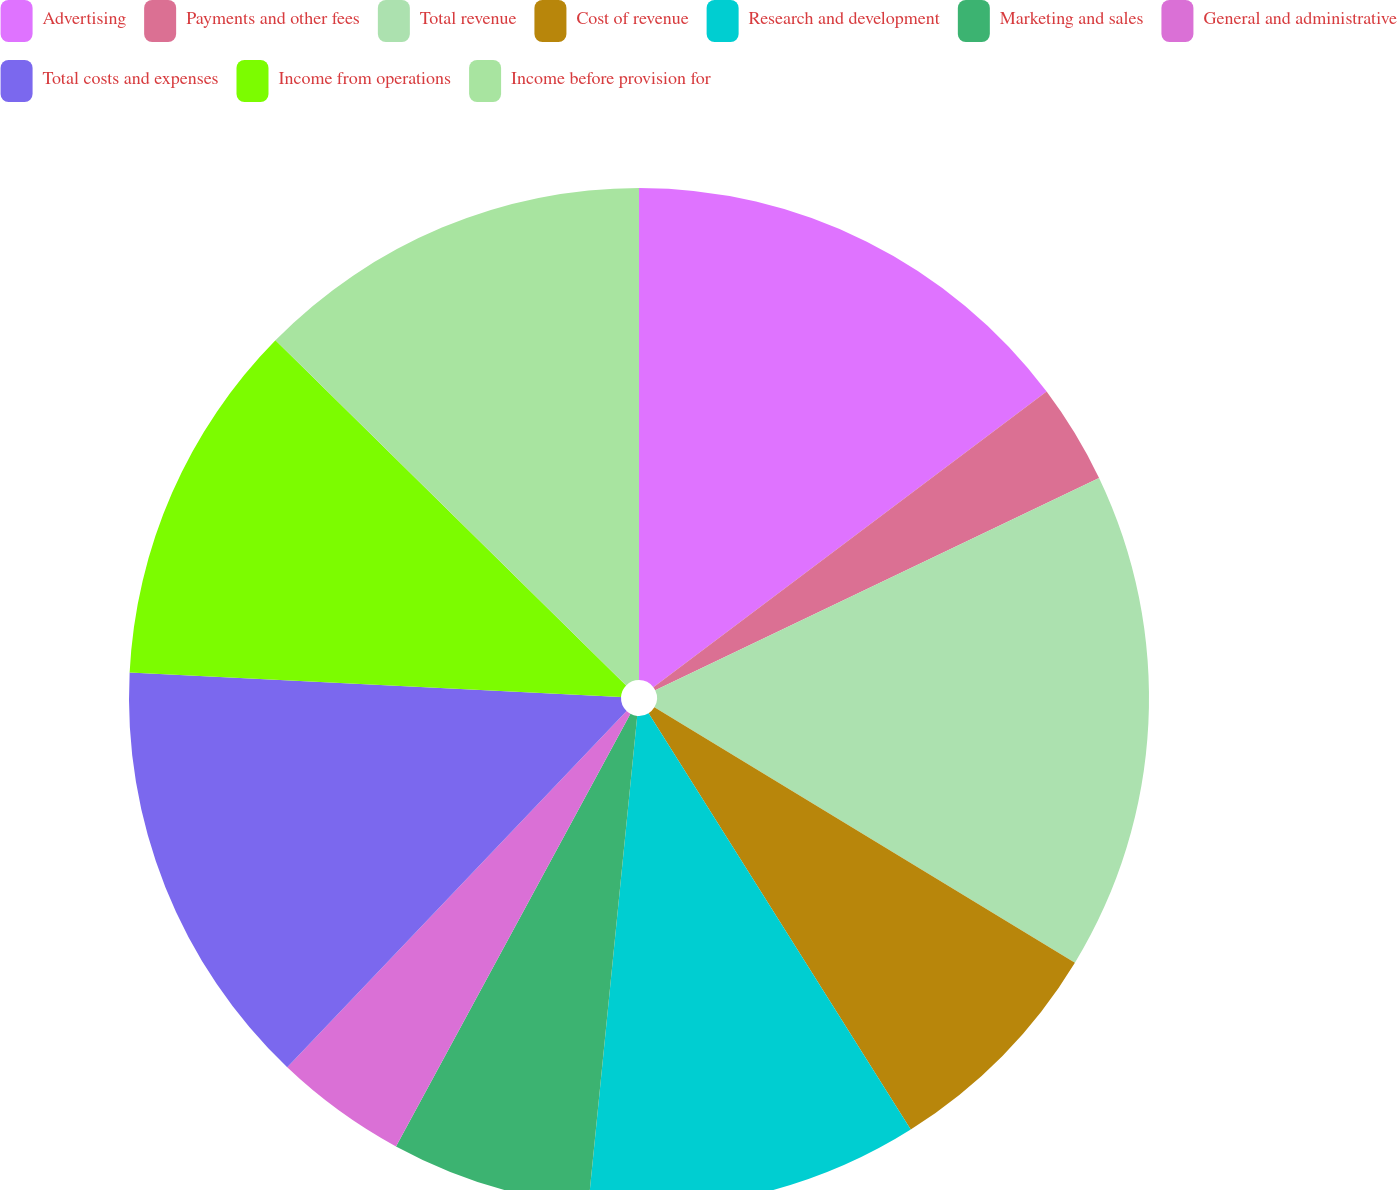Convert chart. <chart><loc_0><loc_0><loc_500><loc_500><pie_chart><fcel>Advertising<fcel>Payments and other fees<fcel>Total revenue<fcel>Cost of revenue<fcel>Research and development<fcel>Marketing and sales<fcel>General and administrative<fcel>Total costs and expenses<fcel>Income from operations<fcel>Income before provision for<nl><fcel>14.74%<fcel>3.16%<fcel>15.79%<fcel>7.37%<fcel>10.53%<fcel>6.32%<fcel>4.21%<fcel>13.68%<fcel>11.58%<fcel>12.63%<nl></chart> 